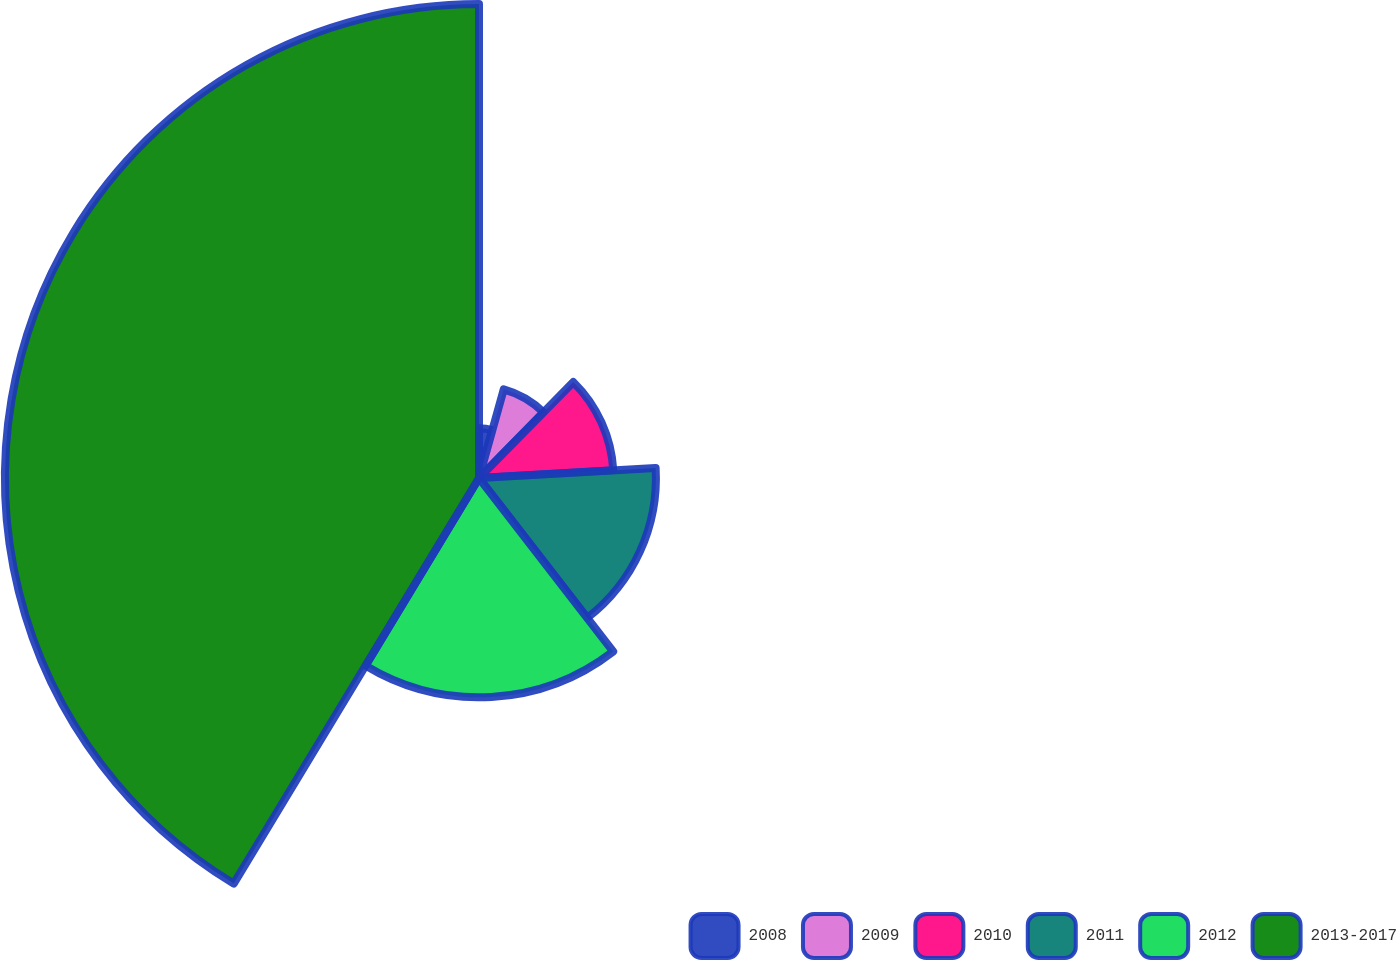Convert chart. <chart><loc_0><loc_0><loc_500><loc_500><pie_chart><fcel>2008<fcel>2009<fcel>2010<fcel>2011<fcel>2012<fcel>2013-2017<nl><fcel>4.33%<fcel>8.03%<fcel>11.73%<fcel>15.43%<fcel>19.13%<fcel>41.34%<nl></chart> 